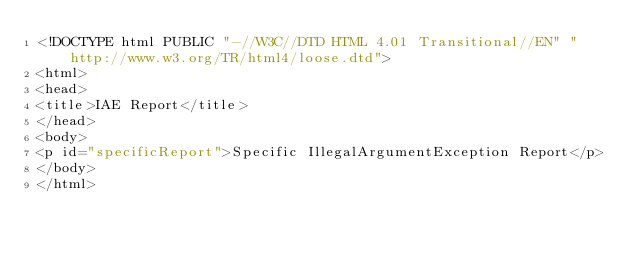Convert code to text. <code><loc_0><loc_0><loc_500><loc_500><_XML_><!DOCTYPE html PUBLIC "-//W3C//DTD HTML 4.01 Transitional//EN" "http://www.w3.org/TR/html4/loose.dtd">
<html>
<head>
<title>IAE Report</title>
</head>
<body>
<p id="specificReport">Specific IllegalArgumentException Report</p>
</body>
</html></code> 